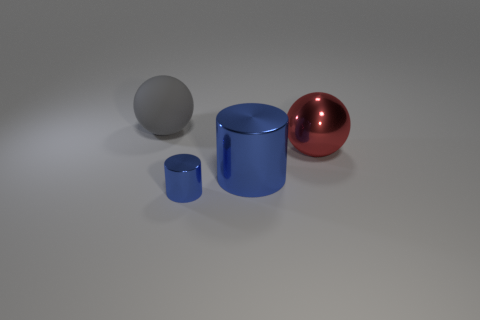Add 1 small gray rubber objects. How many objects exist? 5 Subtract 1 red balls. How many objects are left? 3 Subtract all small purple shiny blocks. Subtract all balls. How many objects are left? 2 Add 2 rubber objects. How many rubber objects are left? 3 Add 2 metallic cubes. How many metallic cubes exist? 2 